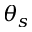Convert formula to latex. <formula><loc_0><loc_0><loc_500><loc_500>\theta _ { s }</formula> 